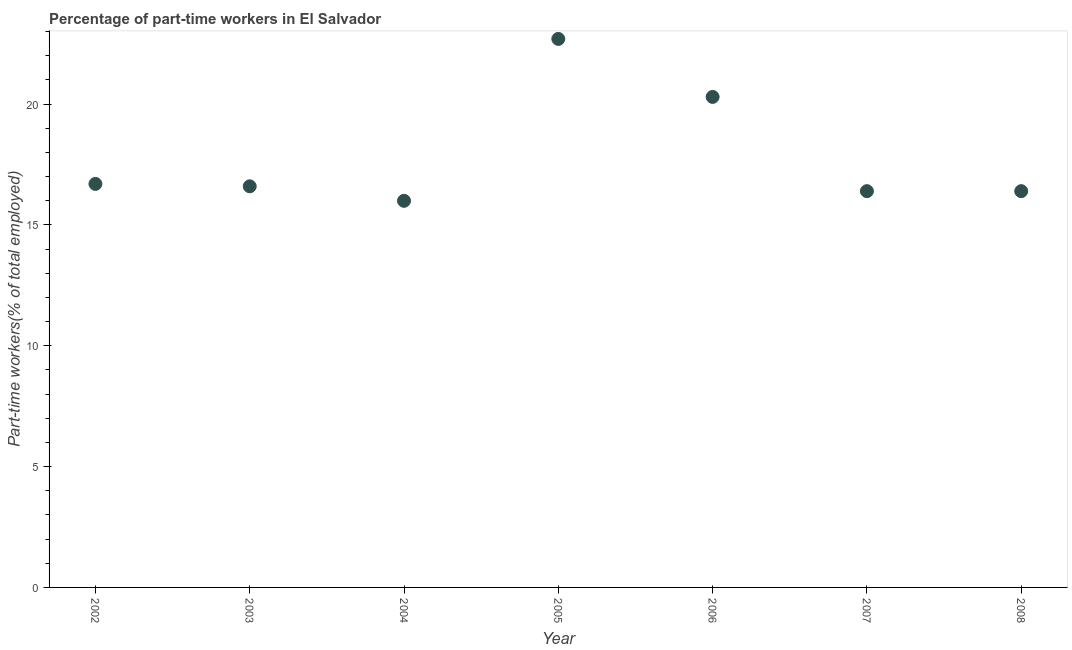What is the percentage of part-time workers in 2002?
Your answer should be compact. 16.7. Across all years, what is the maximum percentage of part-time workers?
Offer a very short reply. 22.7. Across all years, what is the minimum percentage of part-time workers?
Provide a succinct answer. 16. In which year was the percentage of part-time workers maximum?
Make the answer very short. 2005. In which year was the percentage of part-time workers minimum?
Keep it short and to the point. 2004. What is the sum of the percentage of part-time workers?
Your answer should be compact. 125.1. What is the difference between the percentage of part-time workers in 2003 and 2007?
Your response must be concise. 0.2. What is the average percentage of part-time workers per year?
Your answer should be compact. 17.87. What is the median percentage of part-time workers?
Provide a short and direct response. 16.6. In how many years, is the percentage of part-time workers greater than 7 %?
Ensure brevity in your answer.  7. What is the ratio of the percentage of part-time workers in 2004 to that in 2005?
Keep it short and to the point. 0.7. Is the percentage of part-time workers in 2003 less than that in 2007?
Provide a succinct answer. No. What is the difference between the highest and the second highest percentage of part-time workers?
Make the answer very short. 2.4. Is the sum of the percentage of part-time workers in 2003 and 2004 greater than the maximum percentage of part-time workers across all years?
Your response must be concise. Yes. What is the difference between the highest and the lowest percentage of part-time workers?
Provide a short and direct response. 6.7. Does the percentage of part-time workers monotonically increase over the years?
Provide a short and direct response. No. What is the difference between two consecutive major ticks on the Y-axis?
Give a very brief answer. 5. Does the graph contain any zero values?
Offer a very short reply. No. Does the graph contain grids?
Offer a very short reply. No. What is the title of the graph?
Ensure brevity in your answer.  Percentage of part-time workers in El Salvador. What is the label or title of the Y-axis?
Provide a short and direct response. Part-time workers(% of total employed). What is the Part-time workers(% of total employed) in 2002?
Ensure brevity in your answer.  16.7. What is the Part-time workers(% of total employed) in 2003?
Offer a terse response. 16.6. What is the Part-time workers(% of total employed) in 2005?
Provide a short and direct response. 22.7. What is the Part-time workers(% of total employed) in 2006?
Offer a terse response. 20.3. What is the Part-time workers(% of total employed) in 2007?
Make the answer very short. 16.4. What is the Part-time workers(% of total employed) in 2008?
Make the answer very short. 16.4. What is the difference between the Part-time workers(% of total employed) in 2002 and 2003?
Your response must be concise. 0.1. What is the difference between the Part-time workers(% of total employed) in 2002 and 2004?
Your answer should be compact. 0.7. What is the difference between the Part-time workers(% of total employed) in 2002 and 2006?
Provide a short and direct response. -3.6. What is the difference between the Part-time workers(% of total employed) in 2002 and 2007?
Provide a short and direct response. 0.3. What is the difference between the Part-time workers(% of total employed) in 2002 and 2008?
Make the answer very short. 0.3. What is the difference between the Part-time workers(% of total employed) in 2003 and 2004?
Keep it short and to the point. 0.6. What is the difference between the Part-time workers(% of total employed) in 2003 and 2005?
Provide a short and direct response. -6.1. What is the difference between the Part-time workers(% of total employed) in 2003 and 2006?
Offer a terse response. -3.7. What is the difference between the Part-time workers(% of total employed) in 2003 and 2008?
Your answer should be very brief. 0.2. What is the difference between the Part-time workers(% of total employed) in 2004 and 2006?
Provide a succinct answer. -4.3. What is the difference between the Part-time workers(% of total employed) in 2005 and 2006?
Provide a short and direct response. 2.4. What is the difference between the Part-time workers(% of total employed) in 2005 and 2007?
Offer a terse response. 6.3. What is the difference between the Part-time workers(% of total employed) in 2006 and 2007?
Your answer should be very brief. 3.9. What is the difference between the Part-time workers(% of total employed) in 2007 and 2008?
Keep it short and to the point. 0. What is the ratio of the Part-time workers(% of total employed) in 2002 to that in 2003?
Give a very brief answer. 1.01. What is the ratio of the Part-time workers(% of total employed) in 2002 to that in 2004?
Your answer should be compact. 1.04. What is the ratio of the Part-time workers(% of total employed) in 2002 to that in 2005?
Your response must be concise. 0.74. What is the ratio of the Part-time workers(% of total employed) in 2002 to that in 2006?
Offer a very short reply. 0.82. What is the ratio of the Part-time workers(% of total employed) in 2002 to that in 2007?
Provide a succinct answer. 1.02. What is the ratio of the Part-time workers(% of total employed) in 2002 to that in 2008?
Make the answer very short. 1.02. What is the ratio of the Part-time workers(% of total employed) in 2003 to that in 2004?
Offer a very short reply. 1.04. What is the ratio of the Part-time workers(% of total employed) in 2003 to that in 2005?
Offer a terse response. 0.73. What is the ratio of the Part-time workers(% of total employed) in 2003 to that in 2006?
Provide a short and direct response. 0.82. What is the ratio of the Part-time workers(% of total employed) in 2004 to that in 2005?
Provide a succinct answer. 0.7. What is the ratio of the Part-time workers(% of total employed) in 2004 to that in 2006?
Provide a succinct answer. 0.79. What is the ratio of the Part-time workers(% of total employed) in 2004 to that in 2007?
Provide a short and direct response. 0.98. What is the ratio of the Part-time workers(% of total employed) in 2004 to that in 2008?
Your answer should be very brief. 0.98. What is the ratio of the Part-time workers(% of total employed) in 2005 to that in 2006?
Ensure brevity in your answer.  1.12. What is the ratio of the Part-time workers(% of total employed) in 2005 to that in 2007?
Give a very brief answer. 1.38. What is the ratio of the Part-time workers(% of total employed) in 2005 to that in 2008?
Provide a short and direct response. 1.38. What is the ratio of the Part-time workers(% of total employed) in 2006 to that in 2007?
Provide a succinct answer. 1.24. What is the ratio of the Part-time workers(% of total employed) in 2006 to that in 2008?
Ensure brevity in your answer.  1.24. 